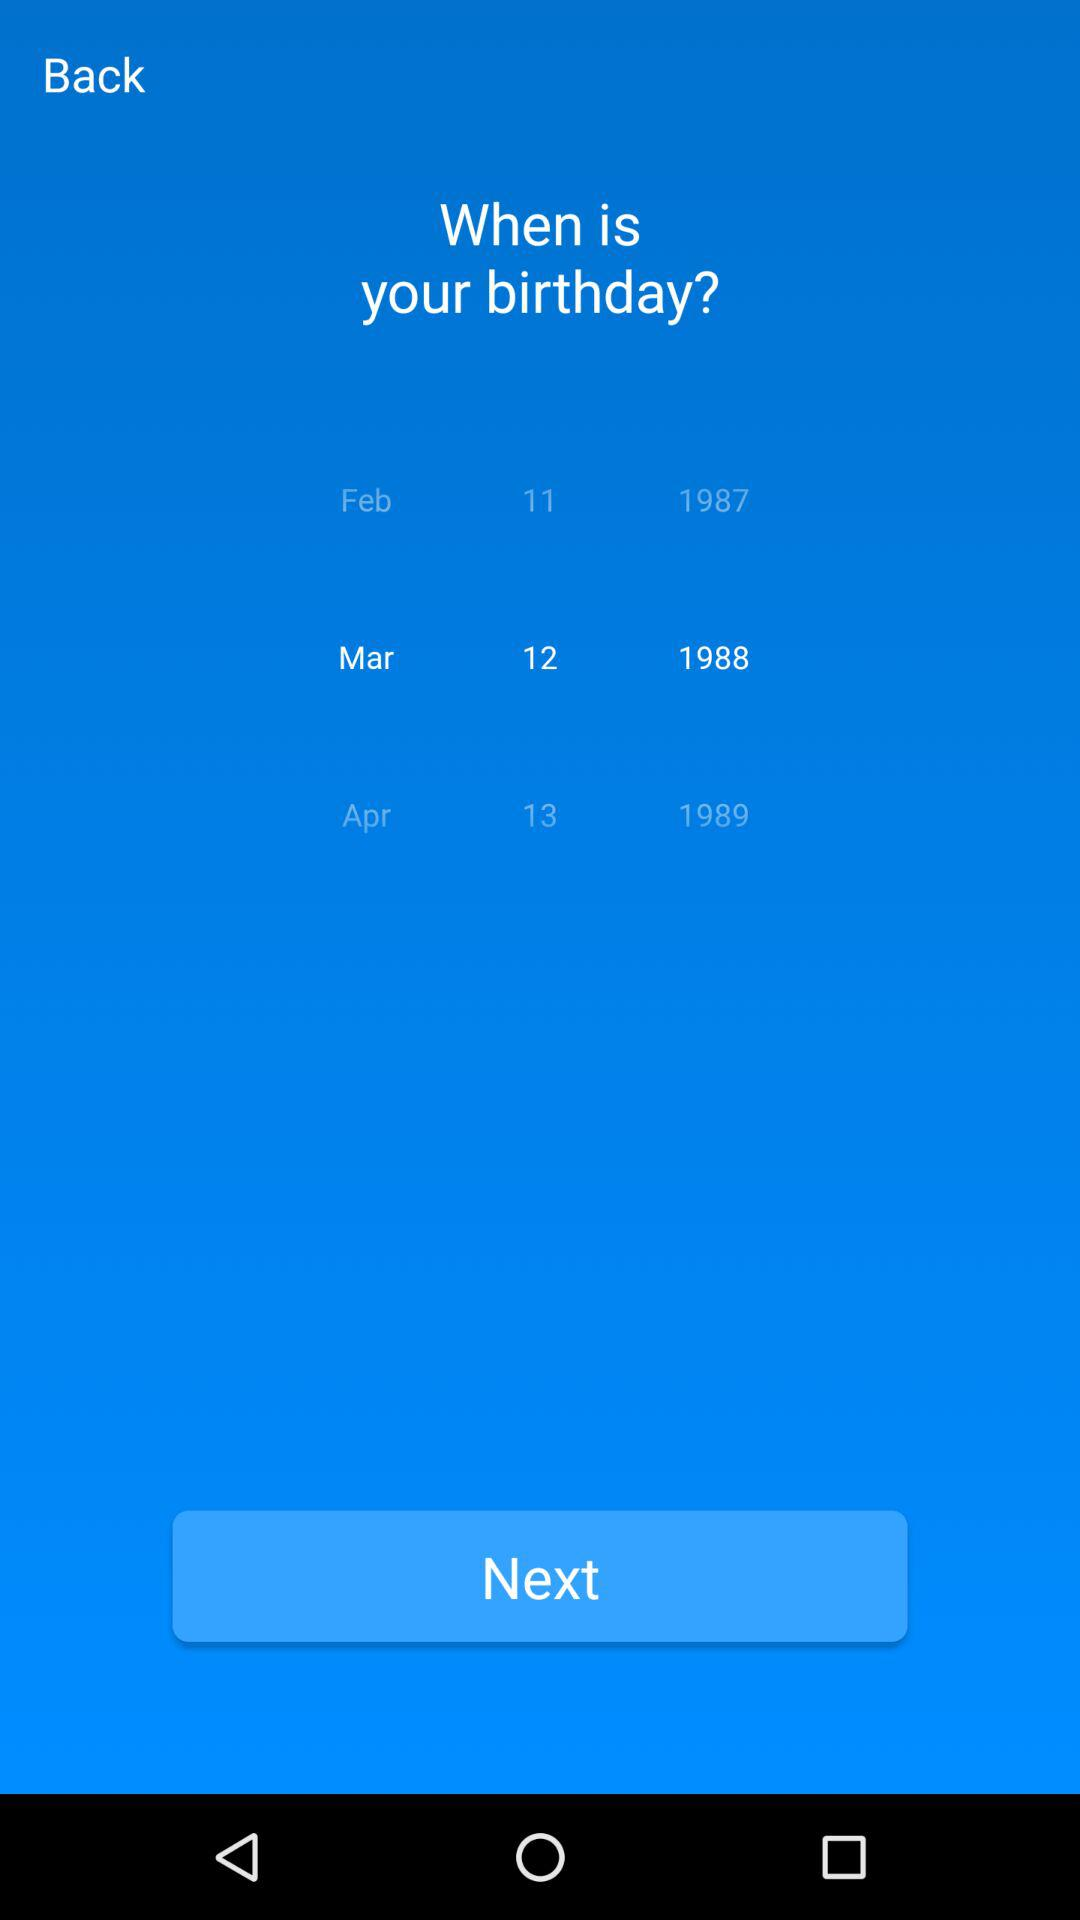Which date is selected? The selected date is March 12, 1988. 